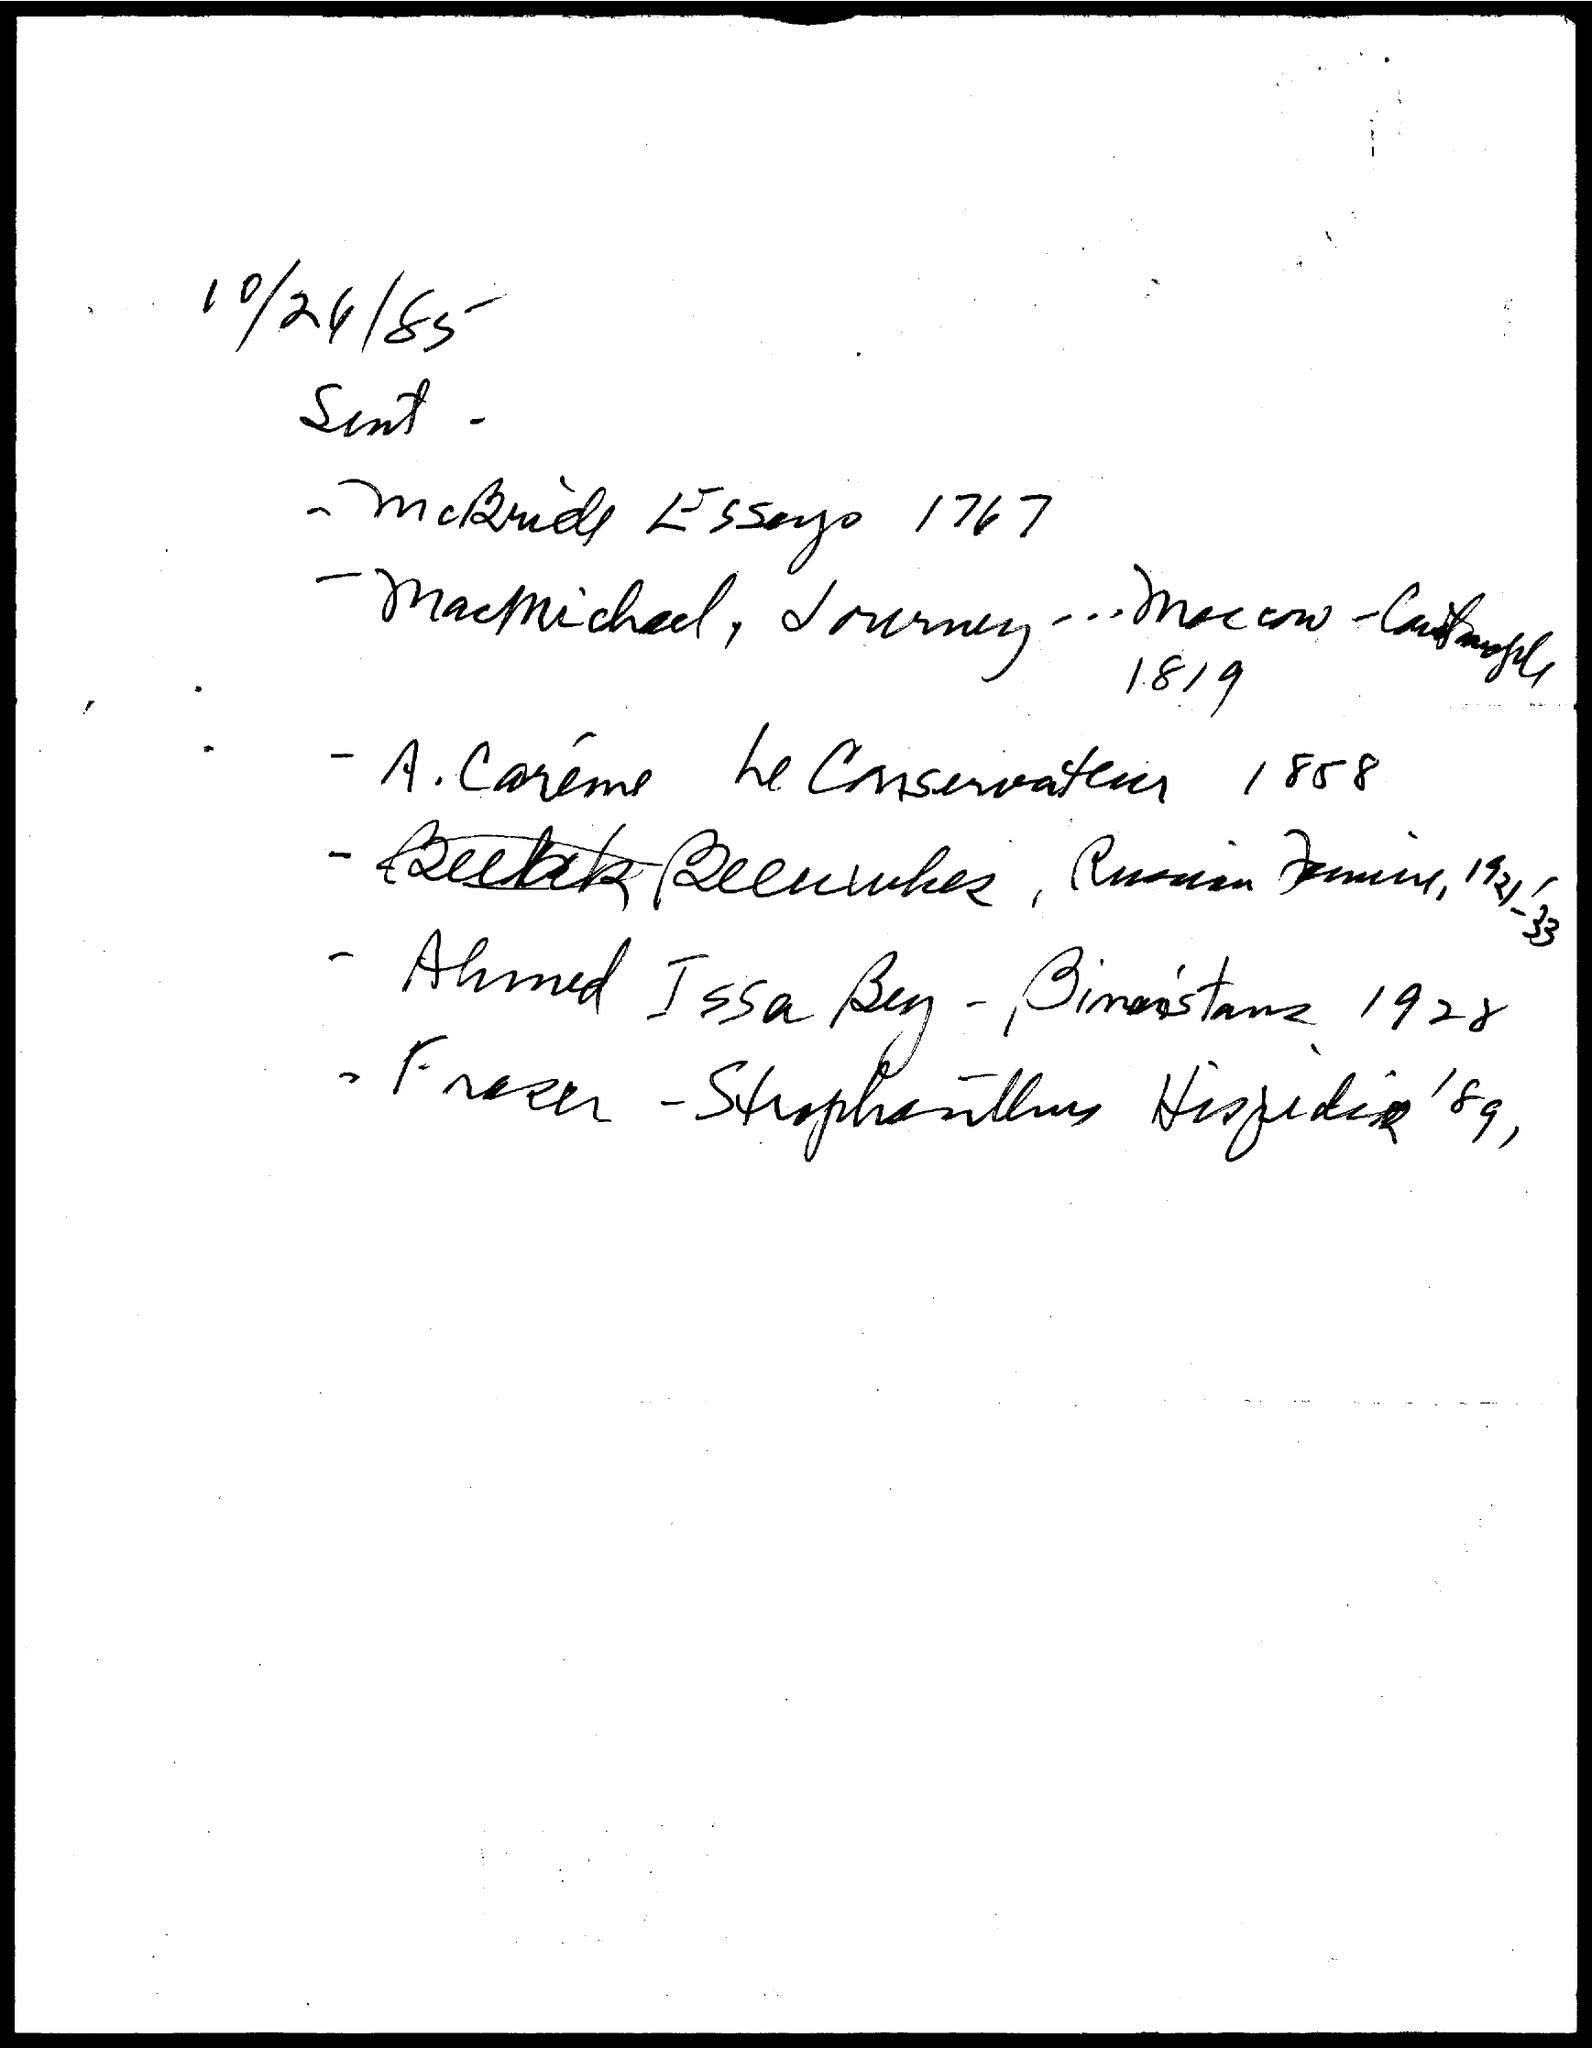Highlight a few significant elements in this photo. The date on the document is October 24, 1985. 